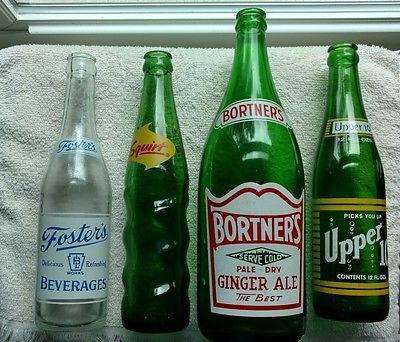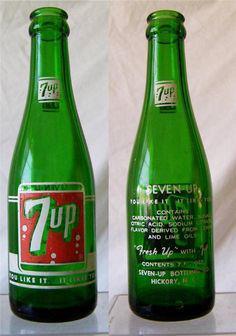The first image is the image on the left, the second image is the image on the right. For the images displayed, is the sentence "There are exactly two green bottles in the right image, and multiple green bottles with a clear bottle in the left image." factually correct? Answer yes or no. Yes. The first image is the image on the left, the second image is the image on the right. Given the left and right images, does the statement "Six or fewer bottles are visible." hold true? Answer yes or no. Yes. 